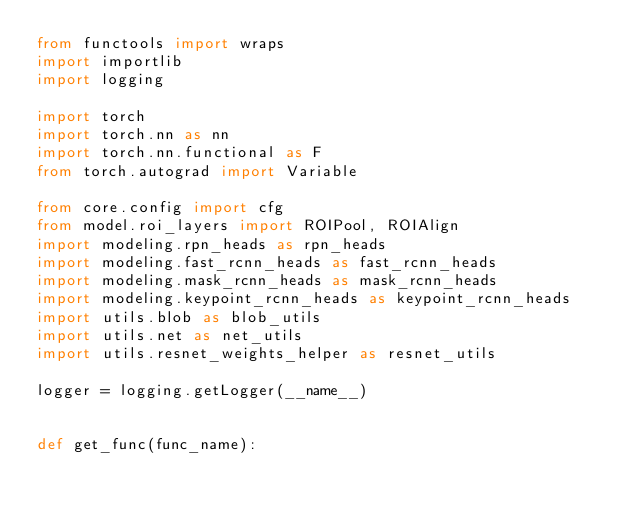Convert code to text. <code><loc_0><loc_0><loc_500><loc_500><_Python_>from functools import wraps
import importlib
import logging

import torch
import torch.nn as nn
import torch.nn.functional as F
from torch.autograd import Variable

from core.config import cfg
from model.roi_layers import ROIPool, ROIAlign
import modeling.rpn_heads as rpn_heads
import modeling.fast_rcnn_heads as fast_rcnn_heads
import modeling.mask_rcnn_heads as mask_rcnn_heads
import modeling.keypoint_rcnn_heads as keypoint_rcnn_heads
import utils.blob as blob_utils
import utils.net as net_utils
import utils.resnet_weights_helper as resnet_utils

logger = logging.getLogger(__name__)


def get_func(func_name):</code> 